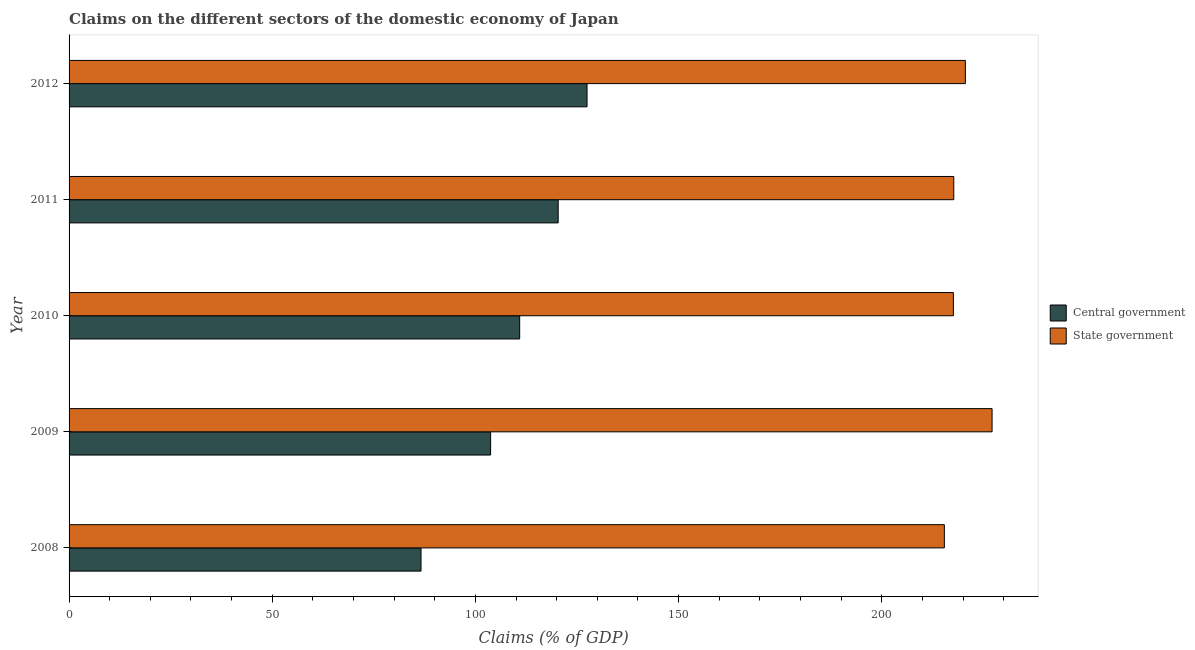How many groups of bars are there?
Ensure brevity in your answer.  5. Are the number of bars on each tick of the Y-axis equal?
Offer a very short reply. Yes. What is the label of the 4th group of bars from the top?
Your response must be concise. 2009. What is the claims on state government in 2008?
Your answer should be very brief. 215.41. Across all years, what is the maximum claims on state government?
Your answer should be compact. 227.15. Across all years, what is the minimum claims on central government?
Your response must be concise. 86.61. In which year was the claims on state government maximum?
Give a very brief answer. 2009. What is the total claims on central government in the graph?
Offer a very short reply. 549.09. What is the difference between the claims on central government in 2010 and that in 2012?
Provide a succinct answer. -16.58. What is the difference between the claims on central government in 2012 and the claims on state government in 2010?
Your answer should be very brief. -90.16. What is the average claims on central government per year?
Your answer should be very brief. 109.82. In the year 2008, what is the difference between the claims on central government and claims on state government?
Ensure brevity in your answer.  -128.79. What is the ratio of the claims on state government in 2009 to that in 2010?
Offer a very short reply. 1.04. Is the claims on state government in 2009 less than that in 2012?
Provide a succinct answer. No. What is the difference between the highest and the second highest claims on central government?
Make the answer very short. 7.11. What is the difference between the highest and the lowest claims on state government?
Offer a terse response. 11.74. In how many years, is the claims on central government greater than the average claims on central government taken over all years?
Provide a succinct answer. 3. Is the sum of the claims on central government in 2008 and 2011 greater than the maximum claims on state government across all years?
Ensure brevity in your answer.  No. What does the 2nd bar from the top in 2009 represents?
Your response must be concise. Central government. What does the 1st bar from the bottom in 2008 represents?
Your answer should be compact. Central government. Are the values on the major ticks of X-axis written in scientific E-notation?
Your answer should be compact. No. Does the graph contain grids?
Make the answer very short. No. Where does the legend appear in the graph?
Offer a terse response. Center right. How are the legend labels stacked?
Your answer should be compact. Vertical. What is the title of the graph?
Make the answer very short. Claims on the different sectors of the domestic economy of Japan. Does "Taxes" appear as one of the legend labels in the graph?
Provide a short and direct response. No. What is the label or title of the X-axis?
Provide a short and direct response. Claims (% of GDP). What is the Claims (% of GDP) in Central government in 2008?
Offer a terse response. 86.61. What is the Claims (% of GDP) of State government in 2008?
Give a very brief answer. 215.41. What is the Claims (% of GDP) in Central government in 2009?
Provide a short and direct response. 103.74. What is the Claims (% of GDP) in State government in 2009?
Make the answer very short. 227.15. What is the Claims (% of GDP) in Central government in 2010?
Provide a succinct answer. 110.89. What is the Claims (% of GDP) of State government in 2010?
Your answer should be very brief. 217.63. What is the Claims (% of GDP) in Central government in 2011?
Ensure brevity in your answer.  120.37. What is the Claims (% of GDP) of State government in 2011?
Provide a short and direct response. 217.72. What is the Claims (% of GDP) in Central government in 2012?
Your response must be concise. 127.47. What is the Claims (% of GDP) of State government in 2012?
Provide a short and direct response. 220.57. Across all years, what is the maximum Claims (% of GDP) in Central government?
Provide a short and direct response. 127.47. Across all years, what is the maximum Claims (% of GDP) in State government?
Ensure brevity in your answer.  227.15. Across all years, what is the minimum Claims (% of GDP) in Central government?
Your response must be concise. 86.61. Across all years, what is the minimum Claims (% of GDP) of State government?
Your response must be concise. 215.41. What is the total Claims (% of GDP) in Central government in the graph?
Offer a terse response. 549.09. What is the total Claims (% of GDP) of State government in the graph?
Your answer should be very brief. 1098.48. What is the difference between the Claims (% of GDP) of Central government in 2008 and that in 2009?
Keep it short and to the point. -17.13. What is the difference between the Claims (% of GDP) of State government in 2008 and that in 2009?
Keep it short and to the point. -11.74. What is the difference between the Claims (% of GDP) of Central government in 2008 and that in 2010?
Make the answer very short. -24.28. What is the difference between the Claims (% of GDP) in State government in 2008 and that in 2010?
Keep it short and to the point. -2.22. What is the difference between the Claims (% of GDP) in Central government in 2008 and that in 2011?
Provide a succinct answer. -33.75. What is the difference between the Claims (% of GDP) in State government in 2008 and that in 2011?
Make the answer very short. -2.32. What is the difference between the Claims (% of GDP) of Central government in 2008 and that in 2012?
Offer a very short reply. -40.86. What is the difference between the Claims (% of GDP) of State government in 2008 and that in 2012?
Provide a short and direct response. -5.17. What is the difference between the Claims (% of GDP) of Central government in 2009 and that in 2010?
Offer a very short reply. -7.15. What is the difference between the Claims (% of GDP) in State government in 2009 and that in 2010?
Your answer should be compact. 9.52. What is the difference between the Claims (% of GDP) of Central government in 2009 and that in 2011?
Offer a very short reply. -16.63. What is the difference between the Claims (% of GDP) of State government in 2009 and that in 2011?
Offer a very short reply. 9.43. What is the difference between the Claims (% of GDP) in Central government in 2009 and that in 2012?
Offer a terse response. -23.73. What is the difference between the Claims (% of GDP) of State government in 2009 and that in 2012?
Keep it short and to the point. 6.58. What is the difference between the Claims (% of GDP) of Central government in 2010 and that in 2011?
Ensure brevity in your answer.  -9.47. What is the difference between the Claims (% of GDP) in State government in 2010 and that in 2011?
Your answer should be very brief. -0.09. What is the difference between the Claims (% of GDP) of Central government in 2010 and that in 2012?
Ensure brevity in your answer.  -16.58. What is the difference between the Claims (% of GDP) of State government in 2010 and that in 2012?
Make the answer very short. -2.94. What is the difference between the Claims (% of GDP) in Central government in 2011 and that in 2012?
Provide a succinct answer. -7.11. What is the difference between the Claims (% of GDP) of State government in 2011 and that in 2012?
Offer a terse response. -2.85. What is the difference between the Claims (% of GDP) of Central government in 2008 and the Claims (% of GDP) of State government in 2009?
Keep it short and to the point. -140.54. What is the difference between the Claims (% of GDP) of Central government in 2008 and the Claims (% of GDP) of State government in 2010?
Your answer should be compact. -131.02. What is the difference between the Claims (% of GDP) in Central government in 2008 and the Claims (% of GDP) in State government in 2011?
Give a very brief answer. -131.11. What is the difference between the Claims (% of GDP) in Central government in 2008 and the Claims (% of GDP) in State government in 2012?
Make the answer very short. -133.96. What is the difference between the Claims (% of GDP) of Central government in 2009 and the Claims (% of GDP) of State government in 2010?
Your answer should be very brief. -113.89. What is the difference between the Claims (% of GDP) in Central government in 2009 and the Claims (% of GDP) in State government in 2011?
Your answer should be compact. -113.98. What is the difference between the Claims (% of GDP) of Central government in 2009 and the Claims (% of GDP) of State government in 2012?
Give a very brief answer. -116.83. What is the difference between the Claims (% of GDP) of Central government in 2010 and the Claims (% of GDP) of State government in 2011?
Ensure brevity in your answer.  -106.83. What is the difference between the Claims (% of GDP) of Central government in 2010 and the Claims (% of GDP) of State government in 2012?
Your response must be concise. -109.68. What is the difference between the Claims (% of GDP) of Central government in 2011 and the Claims (% of GDP) of State government in 2012?
Your answer should be compact. -100.21. What is the average Claims (% of GDP) in Central government per year?
Give a very brief answer. 109.82. What is the average Claims (% of GDP) in State government per year?
Your response must be concise. 219.7. In the year 2008, what is the difference between the Claims (% of GDP) of Central government and Claims (% of GDP) of State government?
Your answer should be very brief. -128.79. In the year 2009, what is the difference between the Claims (% of GDP) of Central government and Claims (% of GDP) of State government?
Provide a short and direct response. -123.41. In the year 2010, what is the difference between the Claims (% of GDP) in Central government and Claims (% of GDP) in State government?
Ensure brevity in your answer.  -106.73. In the year 2011, what is the difference between the Claims (% of GDP) of Central government and Claims (% of GDP) of State government?
Offer a terse response. -97.36. In the year 2012, what is the difference between the Claims (% of GDP) in Central government and Claims (% of GDP) in State government?
Your response must be concise. -93.1. What is the ratio of the Claims (% of GDP) in Central government in 2008 to that in 2009?
Your answer should be very brief. 0.83. What is the ratio of the Claims (% of GDP) of State government in 2008 to that in 2009?
Your answer should be compact. 0.95. What is the ratio of the Claims (% of GDP) in Central government in 2008 to that in 2010?
Your response must be concise. 0.78. What is the ratio of the Claims (% of GDP) in Central government in 2008 to that in 2011?
Keep it short and to the point. 0.72. What is the ratio of the Claims (% of GDP) of State government in 2008 to that in 2011?
Your answer should be compact. 0.99. What is the ratio of the Claims (% of GDP) of Central government in 2008 to that in 2012?
Make the answer very short. 0.68. What is the ratio of the Claims (% of GDP) in State government in 2008 to that in 2012?
Provide a short and direct response. 0.98. What is the ratio of the Claims (% of GDP) of Central government in 2009 to that in 2010?
Give a very brief answer. 0.94. What is the ratio of the Claims (% of GDP) in State government in 2009 to that in 2010?
Offer a very short reply. 1.04. What is the ratio of the Claims (% of GDP) in Central government in 2009 to that in 2011?
Keep it short and to the point. 0.86. What is the ratio of the Claims (% of GDP) of State government in 2009 to that in 2011?
Ensure brevity in your answer.  1.04. What is the ratio of the Claims (% of GDP) of Central government in 2009 to that in 2012?
Offer a very short reply. 0.81. What is the ratio of the Claims (% of GDP) in State government in 2009 to that in 2012?
Ensure brevity in your answer.  1.03. What is the ratio of the Claims (% of GDP) of Central government in 2010 to that in 2011?
Make the answer very short. 0.92. What is the ratio of the Claims (% of GDP) of Central government in 2010 to that in 2012?
Make the answer very short. 0.87. What is the ratio of the Claims (% of GDP) in State government in 2010 to that in 2012?
Offer a very short reply. 0.99. What is the ratio of the Claims (% of GDP) in Central government in 2011 to that in 2012?
Offer a terse response. 0.94. What is the ratio of the Claims (% of GDP) in State government in 2011 to that in 2012?
Keep it short and to the point. 0.99. What is the difference between the highest and the second highest Claims (% of GDP) in Central government?
Give a very brief answer. 7.11. What is the difference between the highest and the second highest Claims (% of GDP) of State government?
Offer a very short reply. 6.58. What is the difference between the highest and the lowest Claims (% of GDP) of Central government?
Provide a succinct answer. 40.86. What is the difference between the highest and the lowest Claims (% of GDP) in State government?
Keep it short and to the point. 11.74. 